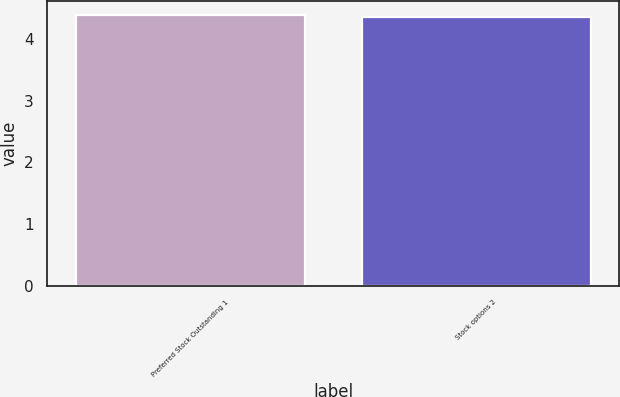<chart> <loc_0><loc_0><loc_500><loc_500><bar_chart><fcel>Preferred Stock Outstanding 1<fcel>Stock options 2<nl><fcel>4.39<fcel>4.35<nl></chart> 